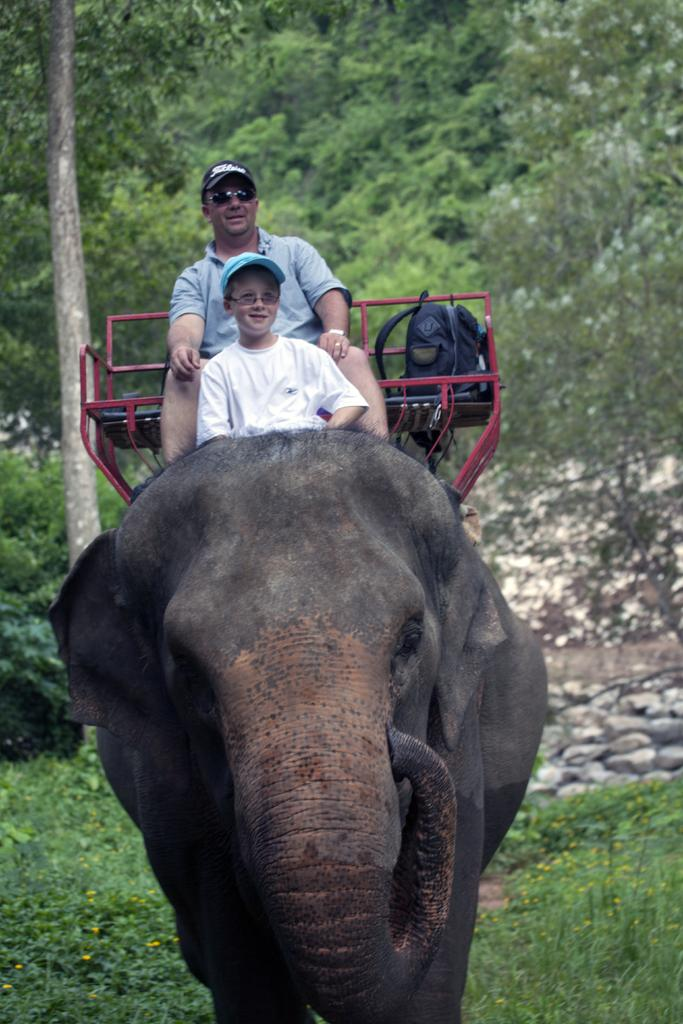Who is present in the image? There is a man and a boy in the image. What are the man and the boy doing in the image? Both the man and the boy are sitting on an elephant. What object can be seen in the image besides the man and the boy? There is a bag in the image. What type of seating is visible in the image? There is a bench in the image. What can be seen in the background of the image? There are trees and stones in the background of the image. What type of button is the man wearing on his back in the image? There is no button visible on the man's back in the image. 